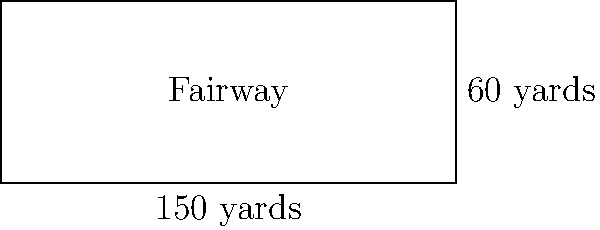Yannik Paul is playing on a golf course where one of the fairways is rectangular in shape. The fairway measures 150 yards in length and 60 yards in width. What is the perimeter of this fairway in yards? To find the perimeter of the rectangular fairway, we need to follow these steps:

1) Recall the formula for the perimeter of a rectangle:
   $$ P = 2l + 2w $$
   where $P$ is the perimeter, $l$ is the length, and $w$ is the width.

2) We are given:
   Length ($l$) = 150 yards
   Width ($w$) = 60 yards

3) Let's substitute these values into the formula:
   $$ P = 2(150) + 2(60) $$

4) Simplify:
   $$ P = 300 + 120 $$

5) Calculate the final result:
   $$ P = 420 $$

Therefore, the perimeter of the fairway is 420 yards.
Answer: 420 yards 